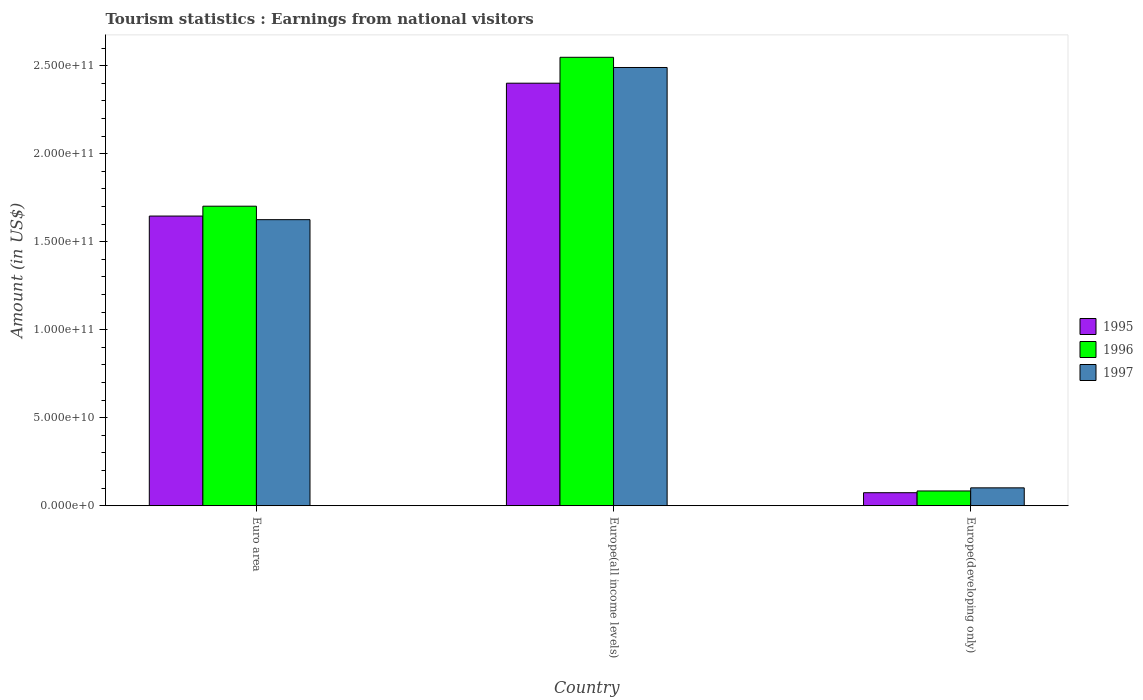How many different coloured bars are there?
Make the answer very short. 3. Are the number of bars per tick equal to the number of legend labels?
Give a very brief answer. Yes. Are the number of bars on each tick of the X-axis equal?
Your response must be concise. Yes. How many bars are there on the 2nd tick from the left?
Provide a short and direct response. 3. What is the label of the 3rd group of bars from the left?
Ensure brevity in your answer.  Europe(developing only). What is the earnings from national visitors in 1995 in Euro area?
Keep it short and to the point. 1.65e+11. Across all countries, what is the maximum earnings from national visitors in 1997?
Your answer should be compact. 2.49e+11. Across all countries, what is the minimum earnings from national visitors in 1996?
Offer a terse response. 8.39e+09. In which country was the earnings from national visitors in 1996 maximum?
Ensure brevity in your answer.  Europe(all income levels). In which country was the earnings from national visitors in 1997 minimum?
Ensure brevity in your answer.  Europe(developing only). What is the total earnings from national visitors in 1997 in the graph?
Give a very brief answer. 4.22e+11. What is the difference between the earnings from national visitors in 1996 in Euro area and that in Europe(all income levels)?
Make the answer very short. -8.46e+1. What is the difference between the earnings from national visitors in 1997 in Euro area and the earnings from national visitors in 1996 in Europe(all income levels)?
Your answer should be compact. -9.23e+1. What is the average earnings from national visitors in 1997 per country?
Make the answer very short. 1.41e+11. What is the difference between the earnings from national visitors of/in 1996 and earnings from national visitors of/in 1997 in Europe(all income levels)?
Offer a terse response. 5.79e+09. In how many countries, is the earnings from national visitors in 1996 greater than 120000000000 US$?
Ensure brevity in your answer.  2. What is the ratio of the earnings from national visitors in 1995 in Europe(all income levels) to that in Europe(developing only)?
Give a very brief answer. 32.48. Is the difference between the earnings from national visitors in 1996 in Euro area and Europe(developing only) greater than the difference between the earnings from national visitors in 1997 in Euro area and Europe(developing only)?
Give a very brief answer. Yes. What is the difference between the highest and the second highest earnings from national visitors in 1997?
Make the answer very short. 1.52e+11. What is the difference between the highest and the lowest earnings from national visitors in 1997?
Make the answer very short. 2.39e+11. Is the sum of the earnings from national visitors in 1996 in Europe(all income levels) and Europe(developing only) greater than the maximum earnings from national visitors in 1995 across all countries?
Offer a terse response. Yes. What does the 1st bar from the right in Euro area represents?
Your answer should be compact. 1997. Is it the case that in every country, the sum of the earnings from national visitors in 1997 and earnings from national visitors in 1996 is greater than the earnings from national visitors in 1995?
Keep it short and to the point. Yes. Are all the bars in the graph horizontal?
Your answer should be very brief. No. How many countries are there in the graph?
Offer a very short reply. 3. What is the difference between two consecutive major ticks on the Y-axis?
Give a very brief answer. 5.00e+1. Are the values on the major ticks of Y-axis written in scientific E-notation?
Offer a terse response. Yes. How many legend labels are there?
Your answer should be compact. 3. How are the legend labels stacked?
Ensure brevity in your answer.  Vertical. What is the title of the graph?
Keep it short and to the point. Tourism statistics : Earnings from national visitors. Does "1973" appear as one of the legend labels in the graph?
Make the answer very short. No. What is the Amount (in US$) of 1995 in Euro area?
Provide a short and direct response. 1.65e+11. What is the Amount (in US$) of 1996 in Euro area?
Your answer should be compact. 1.70e+11. What is the Amount (in US$) of 1997 in Euro area?
Provide a succinct answer. 1.63e+11. What is the Amount (in US$) of 1995 in Europe(all income levels)?
Give a very brief answer. 2.40e+11. What is the Amount (in US$) of 1996 in Europe(all income levels)?
Provide a short and direct response. 2.55e+11. What is the Amount (in US$) in 1997 in Europe(all income levels)?
Ensure brevity in your answer.  2.49e+11. What is the Amount (in US$) of 1995 in Europe(developing only)?
Provide a succinct answer. 7.39e+09. What is the Amount (in US$) in 1996 in Europe(developing only)?
Provide a short and direct response. 8.39e+09. What is the Amount (in US$) of 1997 in Europe(developing only)?
Make the answer very short. 1.02e+1. Across all countries, what is the maximum Amount (in US$) in 1995?
Provide a succinct answer. 2.40e+11. Across all countries, what is the maximum Amount (in US$) in 1996?
Ensure brevity in your answer.  2.55e+11. Across all countries, what is the maximum Amount (in US$) of 1997?
Offer a very short reply. 2.49e+11. Across all countries, what is the minimum Amount (in US$) of 1995?
Ensure brevity in your answer.  7.39e+09. Across all countries, what is the minimum Amount (in US$) of 1996?
Your answer should be very brief. 8.39e+09. Across all countries, what is the minimum Amount (in US$) in 1997?
Offer a terse response. 1.02e+1. What is the total Amount (in US$) in 1995 in the graph?
Give a very brief answer. 4.12e+11. What is the total Amount (in US$) of 1996 in the graph?
Your answer should be very brief. 4.33e+11. What is the total Amount (in US$) in 1997 in the graph?
Ensure brevity in your answer.  4.22e+11. What is the difference between the Amount (in US$) of 1995 in Euro area and that in Europe(all income levels)?
Ensure brevity in your answer.  -7.55e+1. What is the difference between the Amount (in US$) in 1996 in Euro area and that in Europe(all income levels)?
Give a very brief answer. -8.46e+1. What is the difference between the Amount (in US$) in 1997 in Euro area and that in Europe(all income levels)?
Your response must be concise. -8.65e+1. What is the difference between the Amount (in US$) of 1995 in Euro area and that in Europe(developing only)?
Your answer should be very brief. 1.57e+11. What is the difference between the Amount (in US$) of 1996 in Euro area and that in Europe(developing only)?
Ensure brevity in your answer.  1.62e+11. What is the difference between the Amount (in US$) of 1997 in Euro area and that in Europe(developing only)?
Give a very brief answer. 1.52e+11. What is the difference between the Amount (in US$) of 1995 in Europe(all income levels) and that in Europe(developing only)?
Your response must be concise. 2.33e+11. What is the difference between the Amount (in US$) of 1996 in Europe(all income levels) and that in Europe(developing only)?
Offer a very short reply. 2.46e+11. What is the difference between the Amount (in US$) in 1997 in Europe(all income levels) and that in Europe(developing only)?
Provide a succinct answer. 2.39e+11. What is the difference between the Amount (in US$) of 1995 in Euro area and the Amount (in US$) of 1996 in Europe(all income levels)?
Offer a terse response. -9.02e+1. What is the difference between the Amount (in US$) of 1995 in Euro area and the Amount (in US$) of 1997 in Europe(all income levels)?
Give a very brief answer. -8.44e+1. What is the difference between the Amount (in US$) of 1996 in Euro area and the Amount (in US$) of 1997 in Europe(all income levels)?
Give a very brief answer. -7.88e+1. What is the difference between the Amount (in US$) of 1995 in Euro area and the Amount (in US$) of 1996 in Europe(developing only)?
Your response must be concise. 1.56e+11. What is the difference between the Amount (in US$) in 1995 in Euro area and the Amount (in US$) in 1997 in Europe(developing only)?
Provide a short and direct response. 1.54e+11. What is the difference between the Amount (in US$) of 1996 in Euro area and the Amount (in US$) of 1997 in Europe(developing only)?
Provide a short and direct response. 1.60e+11. What is the difference between the Amount (in US$) of 1995 in Europe(all income levels) and the Amount (in US$) of 1996 in Europe(developing only)?
Keep it short and to the point. 2.32e+11. What is the difference between the Amount (in US$) in 1995 in Europe(all income levels) and the Amount (in US$) in 1997 in Europe(developing only)?
Give a very brief answer. 2.30e+11. What is the difference between the Amount (in US$) of 1996 in Europe(all income levels) and the Amount (in US$) of 1997 in Europe(developing only)?
Keep it short and to the point. 2.45e+11. What is the average Amount (in US$) of 1995 per country?
Your answer should be very brief. 1.37e+11. What is the average Amount (in US$) in 1996 per country?
Your answer should be compact. 1.44e+11. What is the average Amount (in US$) of 1997 per country?
Your answer should be very brief. 1.41e+11. What is the difference between the Amount (in US$) of 1995 and Amount (in US$) of 1996 in Euro area?
Provide a short and direct response. -5.60e+09. What is the difference between the Amount (in US$) in 1995 and Amount (in US$) in 1997 in Euro area?
Give a very brief answer. 2.05e+09. What is the difference between the Amount (in US$) in 1996 and Amount (in US$) in 1997 in Euro area?
Your answer should be very brief. 7.66e+09. What is the difference between the Amount (in US$) of 1995 and Amount (in US$) of 1996 in Europe(all income levels)?
Make the answer very short. -1.47e+1. What is the difference between the Amount (in US$) in 1995 and Amount (in US$) in 1997 in Europe(all income levels)?
Your answer should be very brief. -8.92e+09. What is the difference between the Amount (in US$) of 1996 and Amount (in US$) of 1997 in Europe(all income levels)?
Your response must be concise. 5.79e+09. What is the difference between the Amount (in US$) of 1995 and Amount (in US$) of 1996 in Europe(developing only)?
Ensure brevity in your answer.  -9.97e+08. What is the difference between the Amount (in US$) of 1995 and Amount (in US$) of 1997 in Europe(developing only)?
Your response must be concise. -2.77e+09. What is the difference between the Amount (in US$) of 1996 and Amount (in US$) of 1997 in Europe(developing only)?
Provide a short and direct response. -1.77e+09. What is the ratio of the Amount (in US$) in 1995 in Euro area to that in Europe(all income levels)?
Your answer should be very brief. 0.69. What is the ratio of the Amount (in US$) in 1996 in Euro area to that in Europe(all income levels)?
Provide a succinct answer. 0.67. What is the ratio of the Amount (in US$) in 1997 in Euro area to that in Europe(all income levels)?
Your answer should be compact. 0.65. What is the ratio of the Amount (in US$) in 1995 in Euro area to that in Europe(developing only)?
Provide a short and direct response. 22.27. What is the ratio of the Amount (in US$) in 1996 in Euro area to that in Europe(developing only)?
Your response must be concise. 20.29. What is the ratio of the Amount (in US$) in 1997 in Euro area to that in Europe(developing only)?
Provide a short and direct response. 16. What is the ratio of the Amount (in US$) in 1995 in Europe(all income levels) to that in Europe(developing only)?
Keep it short and to the point. 32.48. What is the ratio of the Amount (in US$) in 1996 in Europe(all income levels) to that in Europe(developing only)?
Give a very brief answer. 30.37. What is the ratio of the Amount (in US$) in 1997 in Europe(all income levels) to that in Europe(developing only)?
Provide a short and direct response. 24.51. What is the difference between the highest and the second highest Amount (in US$) of 1995?
Give a very brief answer. 7.55e+1. What is the difference between the highest and the second highest Amount (in US$) in 1996?
Provide a short and direct response. 8.46e+1. What is the difference between the highest and the second highest Amount (in US$) of 1997?
Your response must be concise. 8.65e+1. What is the difference between the highest and the lowest Amount (in US$) in 1995?
Keep it short and to the point. 2.33e+11. What is the difference between the highest and the lowest Amount (in US$) of 1996?
Offer a terse response. 2.46e+11. What is the difference between the highest and the lowest Amount (in US$) of 1997?
Your answer should be compact. 2.39e+11. 